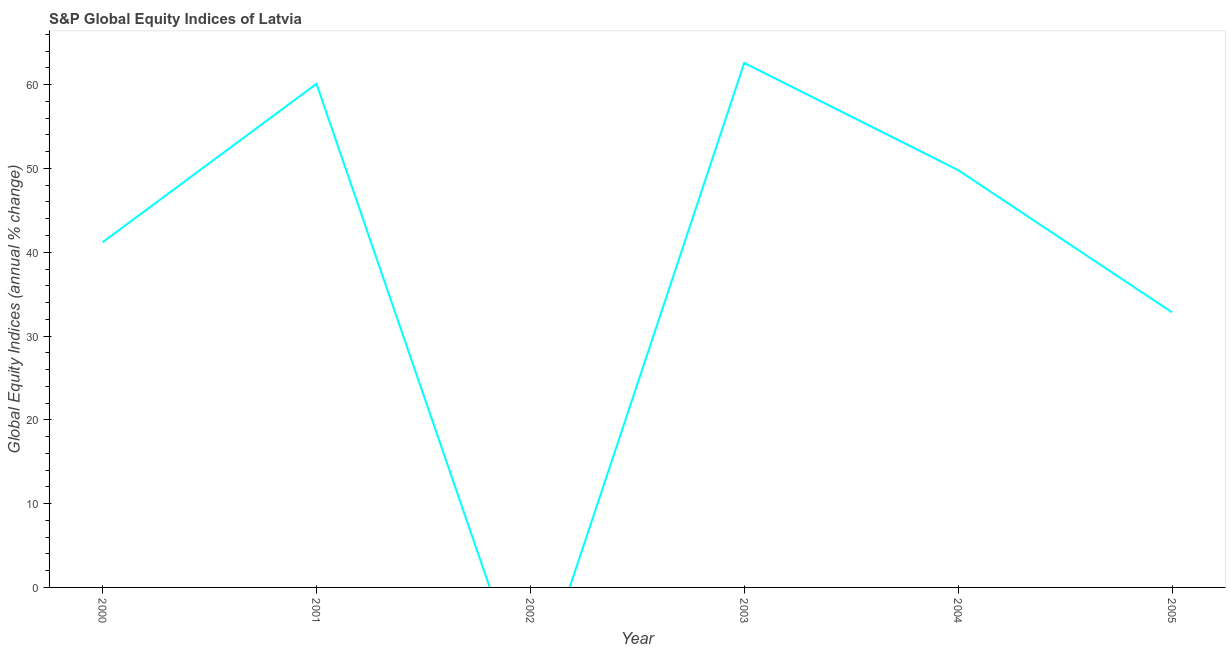What is the s&p global equity indices in 2005?
Your response must be concise. 32.83. Across all years, what is the maximum s&p global equity indices?
Make the answer very short. 62.59. What is the sum of the s&p global equity indices?
Provide a short and direct response. 246.51. What is the difference between the s&p global equity indices in 2003 and 2005?
Ensure brevity in your answer.  29.76. What is the average s&p global equity indices per year?
Make the answer very short. 41.09. What is the median s&p global equity indices?
Offer a very short reply. 45.5. In how many years, is the s&p global equity indices greater than 36 %?
Offer a very short reply. 4. What is the ratio of the s&p global equity indices in 2003 to that in 2004?
Provide a succinct answer. 1.26. Is the s&p global equity indices in 2000 less than that in 2003?
Make the answer very short. Yes. What is the difference between the highest and the second highest s&p global equity indices?
Keep it short and to the point. 2.49. What is the difference between the highest and the lowest s&p global equity indices?
Your answer should be compact. 62.59. In how many years, is the s&p global equity indices greater than the average s&p global equity indices taken over all years?
Keep it short and to the point. 4. How many lines are there?
Provide a short and direct response. 1. Are the values on the major ticks of Y-axis written in scientific E-notation?
Offer a very short reply. No. Does the graph contain any zero values?
Your answer should be very brief. Yes. Does the graph contain grids?
Ensure brevity in your answer.  No. What is the title of the graph?
Ensure brevity in your answer.  S&P Global Equity Indices of Latvia. What is the label or title of the X-axis?
Your answer should be very brief. Year. What is the label or title of the Y-axis?
Your answer should be very brief. Global Equity Indices (annual % change). What is the Global Equity Indices (annual % change) in 2000?
Ensure brevity in your answer.  41.19. What is the Global Equity Indices (annual % change) in 2001?
Your answer should be compact. 60.1. What is the Global Equity Indices (annual % change) of 2003?
Offer a terse response. 62.59. What is the Global Equity Indices (annual % change) in 2004?
Provide a succinct answer. 49.8. What is the Global Equity Indices (annual % change) in 2005?
Provide a short and direct response. 32.83. What is the difference between the Global Equity Indices (annual % change) in 2000 and 2001?
Your answer should be very brief. -18.91. What is the difference between the Global Equity Indices (annual % change) in 2000 and 2003?
Ensure brevity in your answer.  -21.4. What is the difference between the Global Equity Indices (annual % change) in 2000 and 2004?
Make the answer very short. -8.61. What is the difference between the Global Equity Indices (annual % change) in 2000 and 2005?
Your answer should be very brief. 8.36. What is the difference between the Global Equity Indices (annual % change) in 2001 and 2003?
Give a very brief answer. -2.49. What is the difference between the Global Equity Indices (annual % change) in 2001 and 2004?
Make the answer very short. 10.3. What is the difference between the Global Equity Indices (annual % change) in 2001 and 2005?
Your answer should be compact. 27.27. What is the difference between the Global Equity Indices (annual % change) in 2003 and 2004?
Ensure brevity in your answer.  12.79. What is the difference between the Global Equity Indices (annual % change) in 2003 and 2005?
Your response must be concise. 29.76. What is the difference between the Global Equity Indices (annual % change) in 2004 and 2005?
Your answer should be very brief. 16.97. What is the ratio of the Global Equity Indices (annual % change) in 2000 to that in 2001?
Your answer should be compact. 0.69. What is the ratio of the Global Equity Indices (annual % change) in 2000 to that in 2003?
Provide a succinct answer. 0.66. What is the ratio of the Global Equity Indices (annual % change) in 2000 to that in 2004?
Your answer should be very brief. 0.83. What is the ratio of the Global Equity Indices (annual % change) in 2000 to that in 2005?
Ensure brevity in your answer.  1.25. What is the ratio of the Global Equity Indices (annual % change) in 2001 to that in 2003?
Provide a short and direct response. 0.96. What is the ratio of the Global Equity Indices (annual % change) in 2001 to that in 2004?
Provide a short and direct response. 1.21. What is the ratio of the Global Equity Indices (annual % change) in 2001 to that in 2005?
Offer a very short reply. 1.83. What is the ratio of the Global Equity Indices (annual % change) in 2003 to that in 2004?
Offer a terse response. 1.26. What is the ratio of the Global Equity Indices (annual % change) in 2003 to that in 2005?
Provide a succinct answer. 1.91. What is the ratio of the Global Equity Indices (annual % change) in 2004 to that in 2005?
Ensure brevity in your answer.  1.52. 